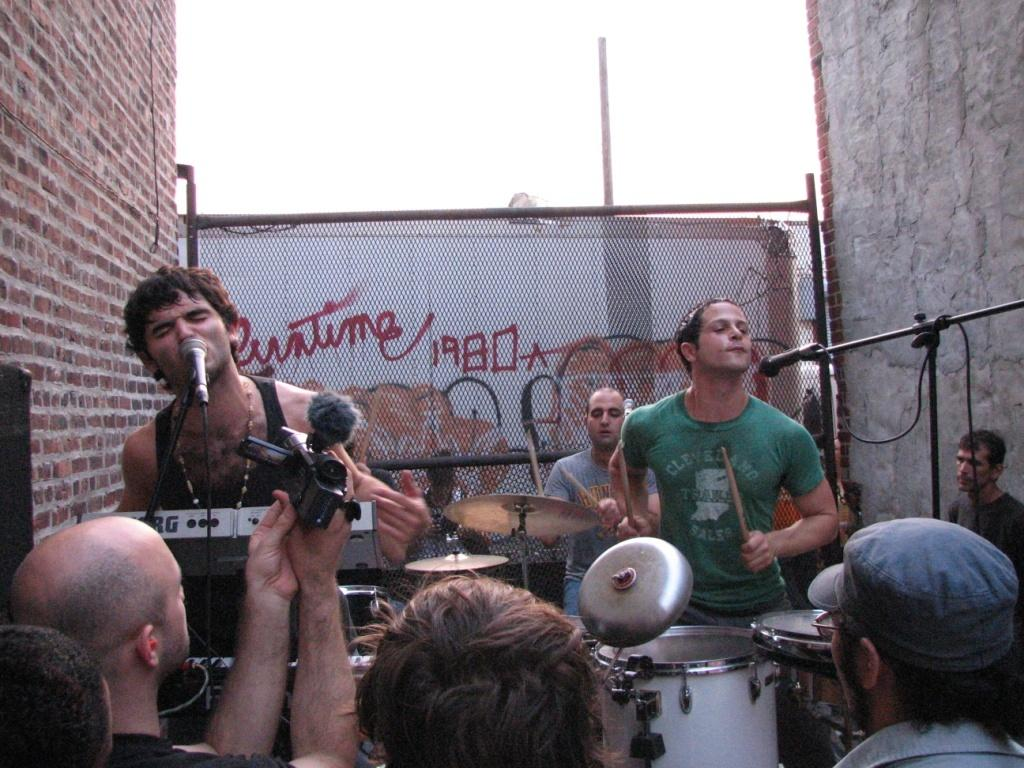What are the people in the image doing? The people in the image are singing. How are the singers amplifying their voices? The people are using microphones. Are there any people sitting in the image? Yes, there are people sitting in the image. What can be seen in the background of the image? There is a brown color wall in the background of the image. What type of ice can be seen hanging from the hook in the image? There is no ice or hook present in the image. What does the image need to be complete? The image is already complete as it is, and no additional elements are needed. 